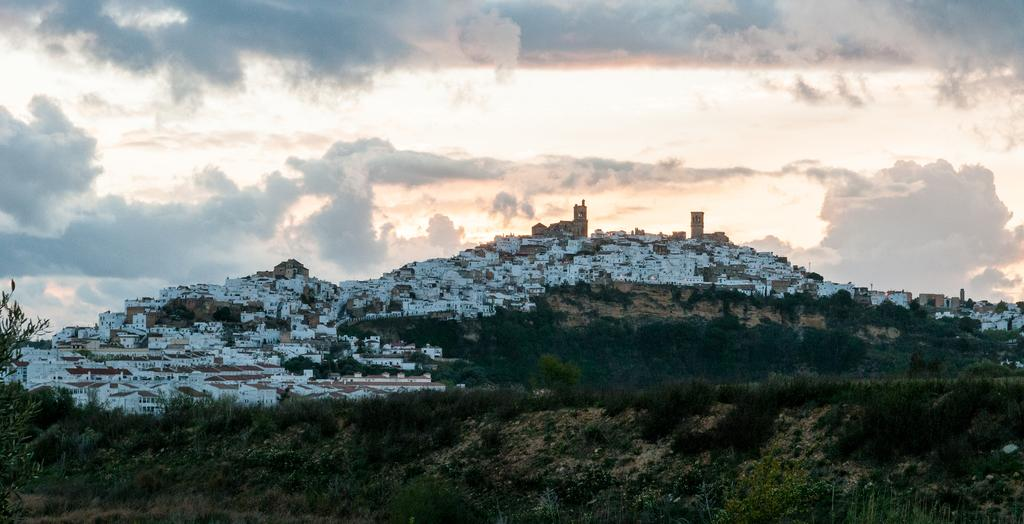What type of view is shown in the image? The image depicts a beautiful view of the city. What can be seen at the top of the image? The sky is visible at the top of the image. How are the houses and buildings arranged in the image? The houses and buildings are situated close to one another. What is present at the bottom of the image? There are plants and sand at the bottom of the image. What type of skirt can be seen on the truck in the image? There is no truck or skirt present in the image. How many birds are visible in the image? There are no birds visible in the image. 